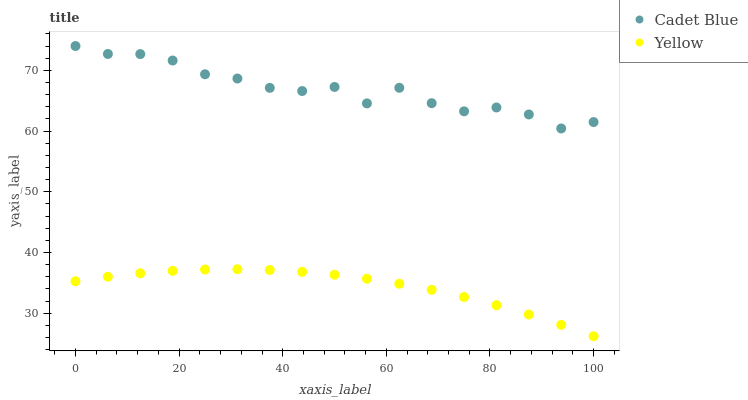Does Yellow have the minimum area under the curve?
Answer yes or no. Yes. Does Cadet Blue have the maximum area under the curve?
Answer yes or no. Yes. Does Yellow have the maximum area under the curve?
Answer yes or no. No. Is Yellow the smoothest?
Answer yes or no. Yes. Is Cadet Blue the roughest?
Answer yes or no. Yes. Is Yellow the roughest?
Answer yes or no. No. Does Yellow have the lowest value?
Answer yes or no. Yes. Does Cadet Blue have the highest value?
Answer yes or no. Yes. Does Yellow have the highest value?
Answer yes or no. No. Is Yellow less than Cadet Blue?
Answer yes or no. Yes. Is Cadet Blue greater than Yellow?
Answer yes or no. Yes. Does Yellow intersect Cadet Blue?
Answer yes or no. No. 